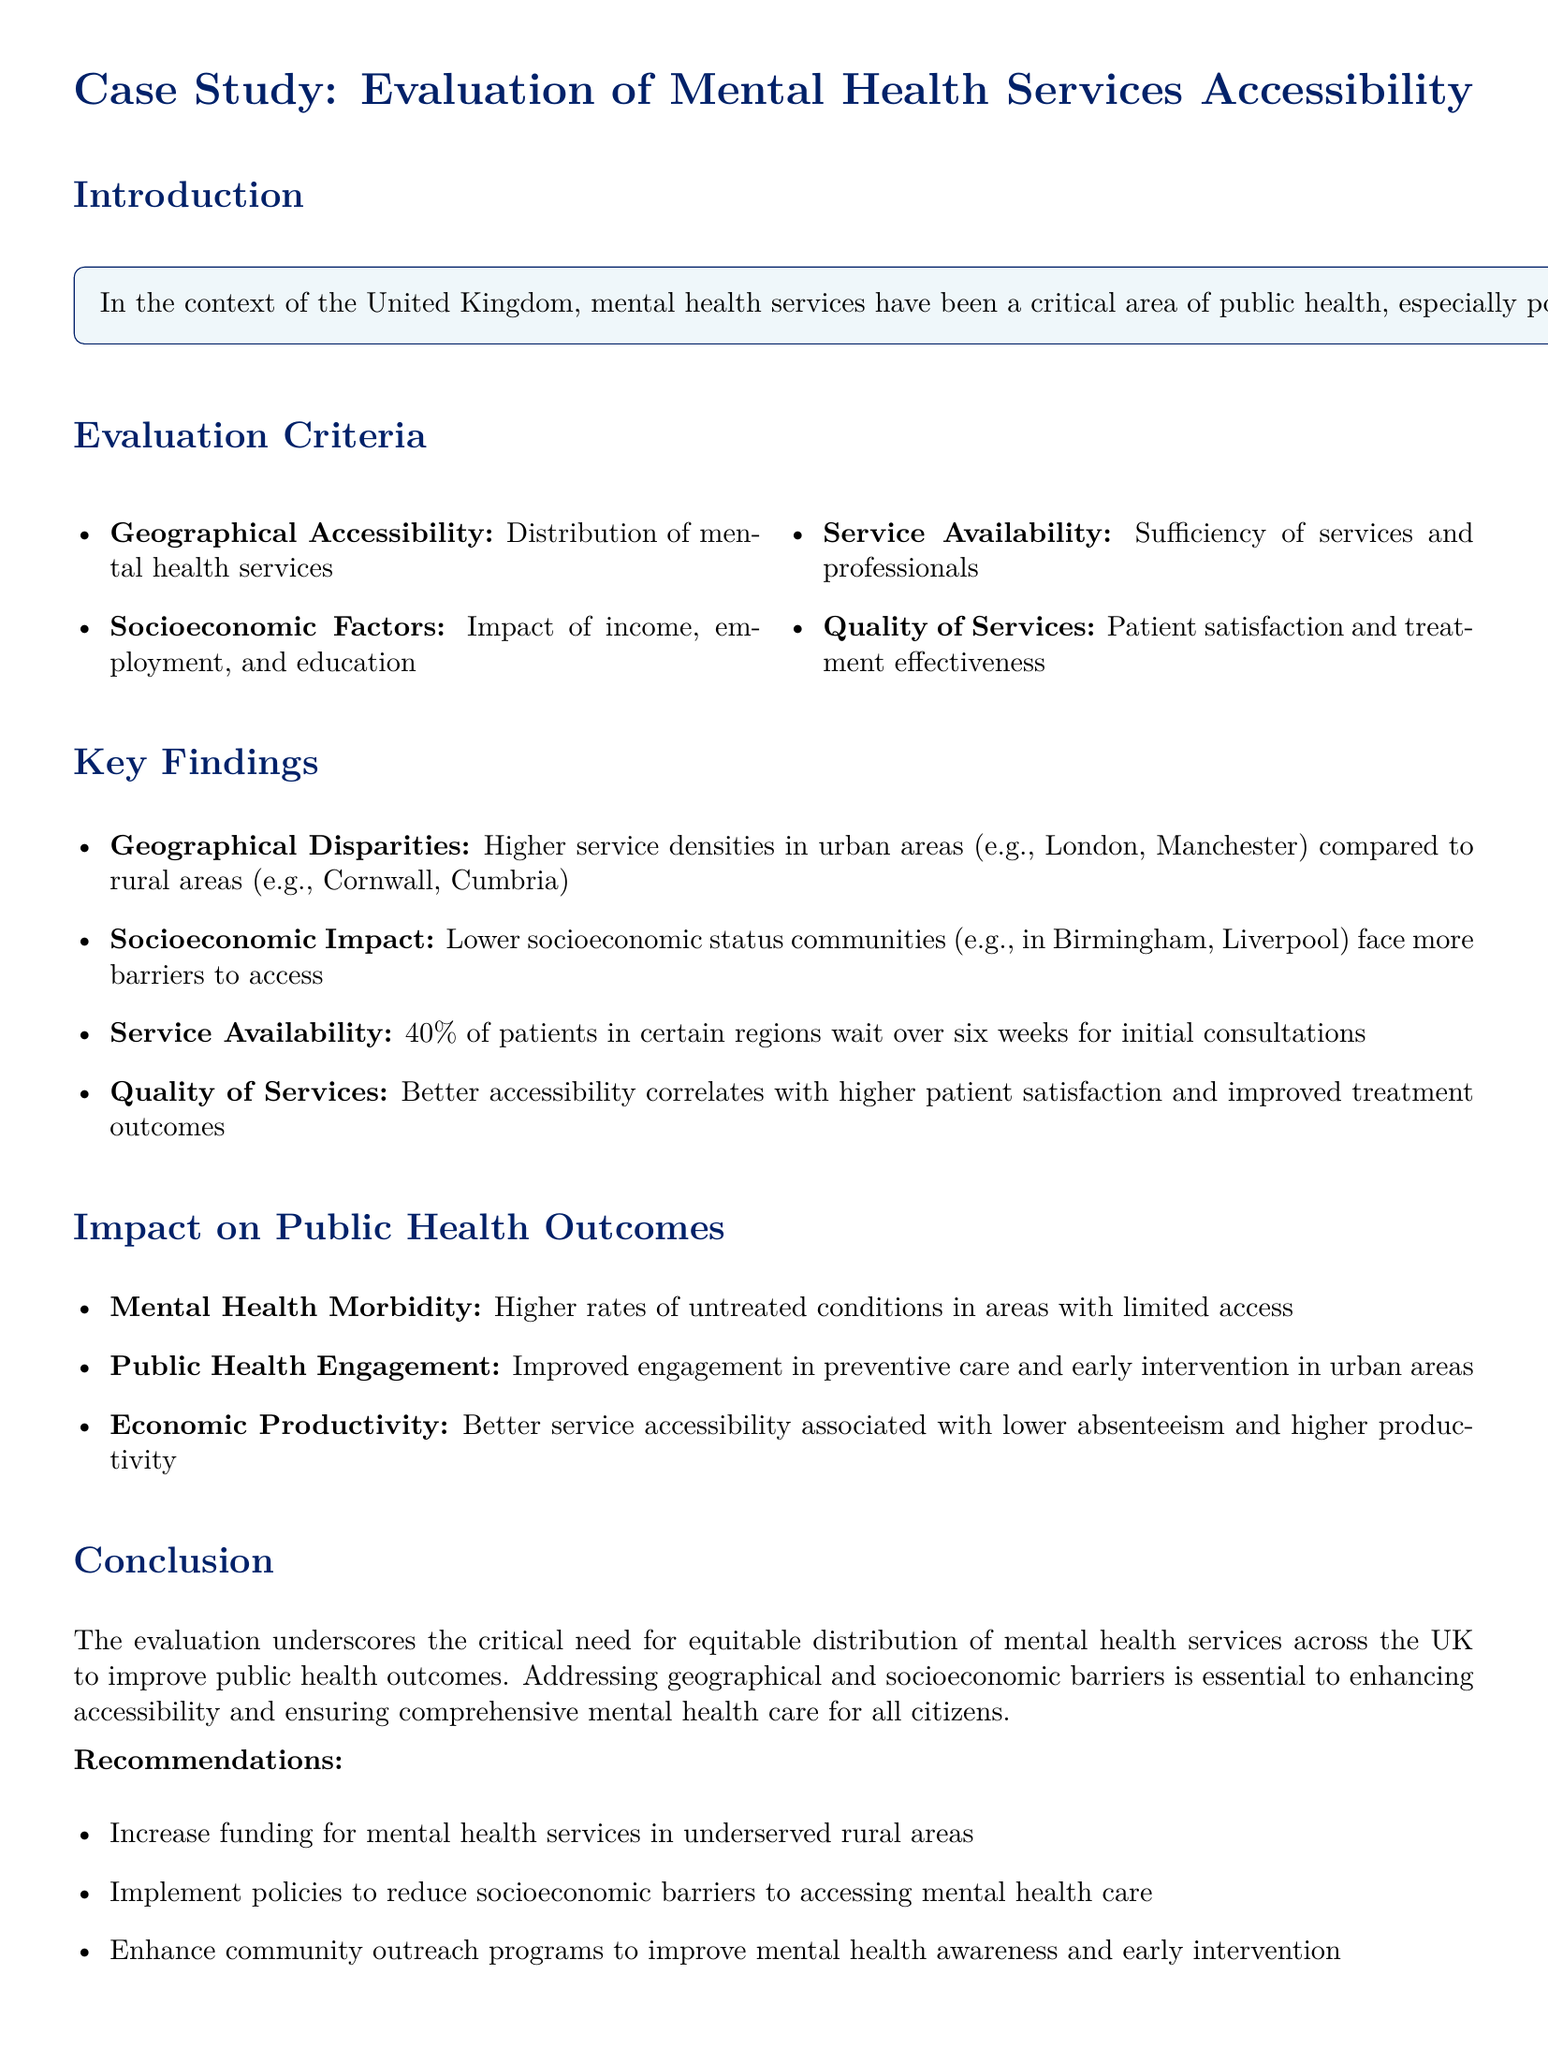what is the primary focus of the case study? The primary focus of the case study is to evaluate the accessibility of mental health services in the UK and its impact on public health outcomes.
Answer: accessibility of mental health services which organization provided comprehensive data for the case study? The case study used comprehensive data from NHS Digital, Public Health England, and relevant academic research.
Answer: NHS Digital how many patients in certain regions wait over six weeks for initial consultations? The document states that 40% of patients in certain regions wait over six weeks for initial consultations.
Answer: 40% what is a recommended action to improve mental health services in underserved areas? The recommendations include increasing funding for mental health services in underserved rural areas.
Answer: increase funding what correlation is noted in the quality of services section? The quality of services section mentions that better accessibility correlates with higher patient satisfaction and improved treatment outcomes.
Answer: higher patient satisfaction which areas in the UK are mentioned as having higher service densities? The areas mentioned with higher service densities are urban areas like London and Manchester.
Answer: London, Manchester how are lower socioeconomic status communities affected according to the findings? Lower socioeconomic status communities face more barriers to access mental health services.
Answer: more barriers to access what is one public health outcome associated with better service accessibility? Better service accessibility is associated with lower absenteeism and higher productivity.
Answer: lower absenteeism what is highlighted as a critical need in the conclusion? The conclusion underscores the critical need for equitable distribution of mental health services across the UK.
Answer: equitable distribution 